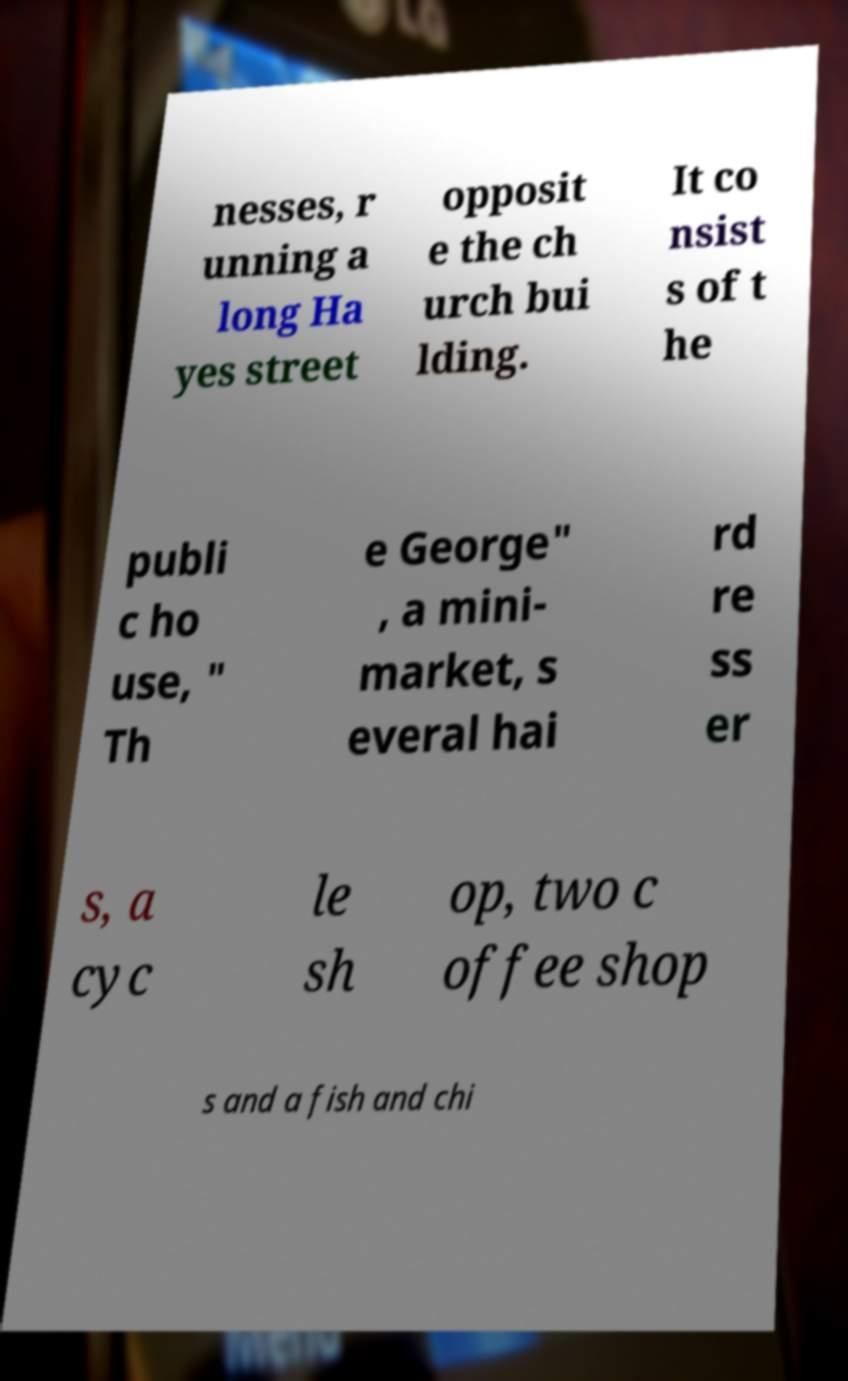Could you extract and type out the text from this image? nesses, r unning a long Ha yes street opposit e the ch urch bui lding. It co nsist s of t he publi c ho use, " Th e George" , a mini- market, s everal hai rd re ss er s, a cyc le sh op, two c offee shop s and a fish and chi 